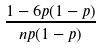<formula> <loc_0><loc_0><loc_500><loc_500>\frac { 1 - 6 p ( 1 - p ) } { n p ( 1 - p ) }</formula> 